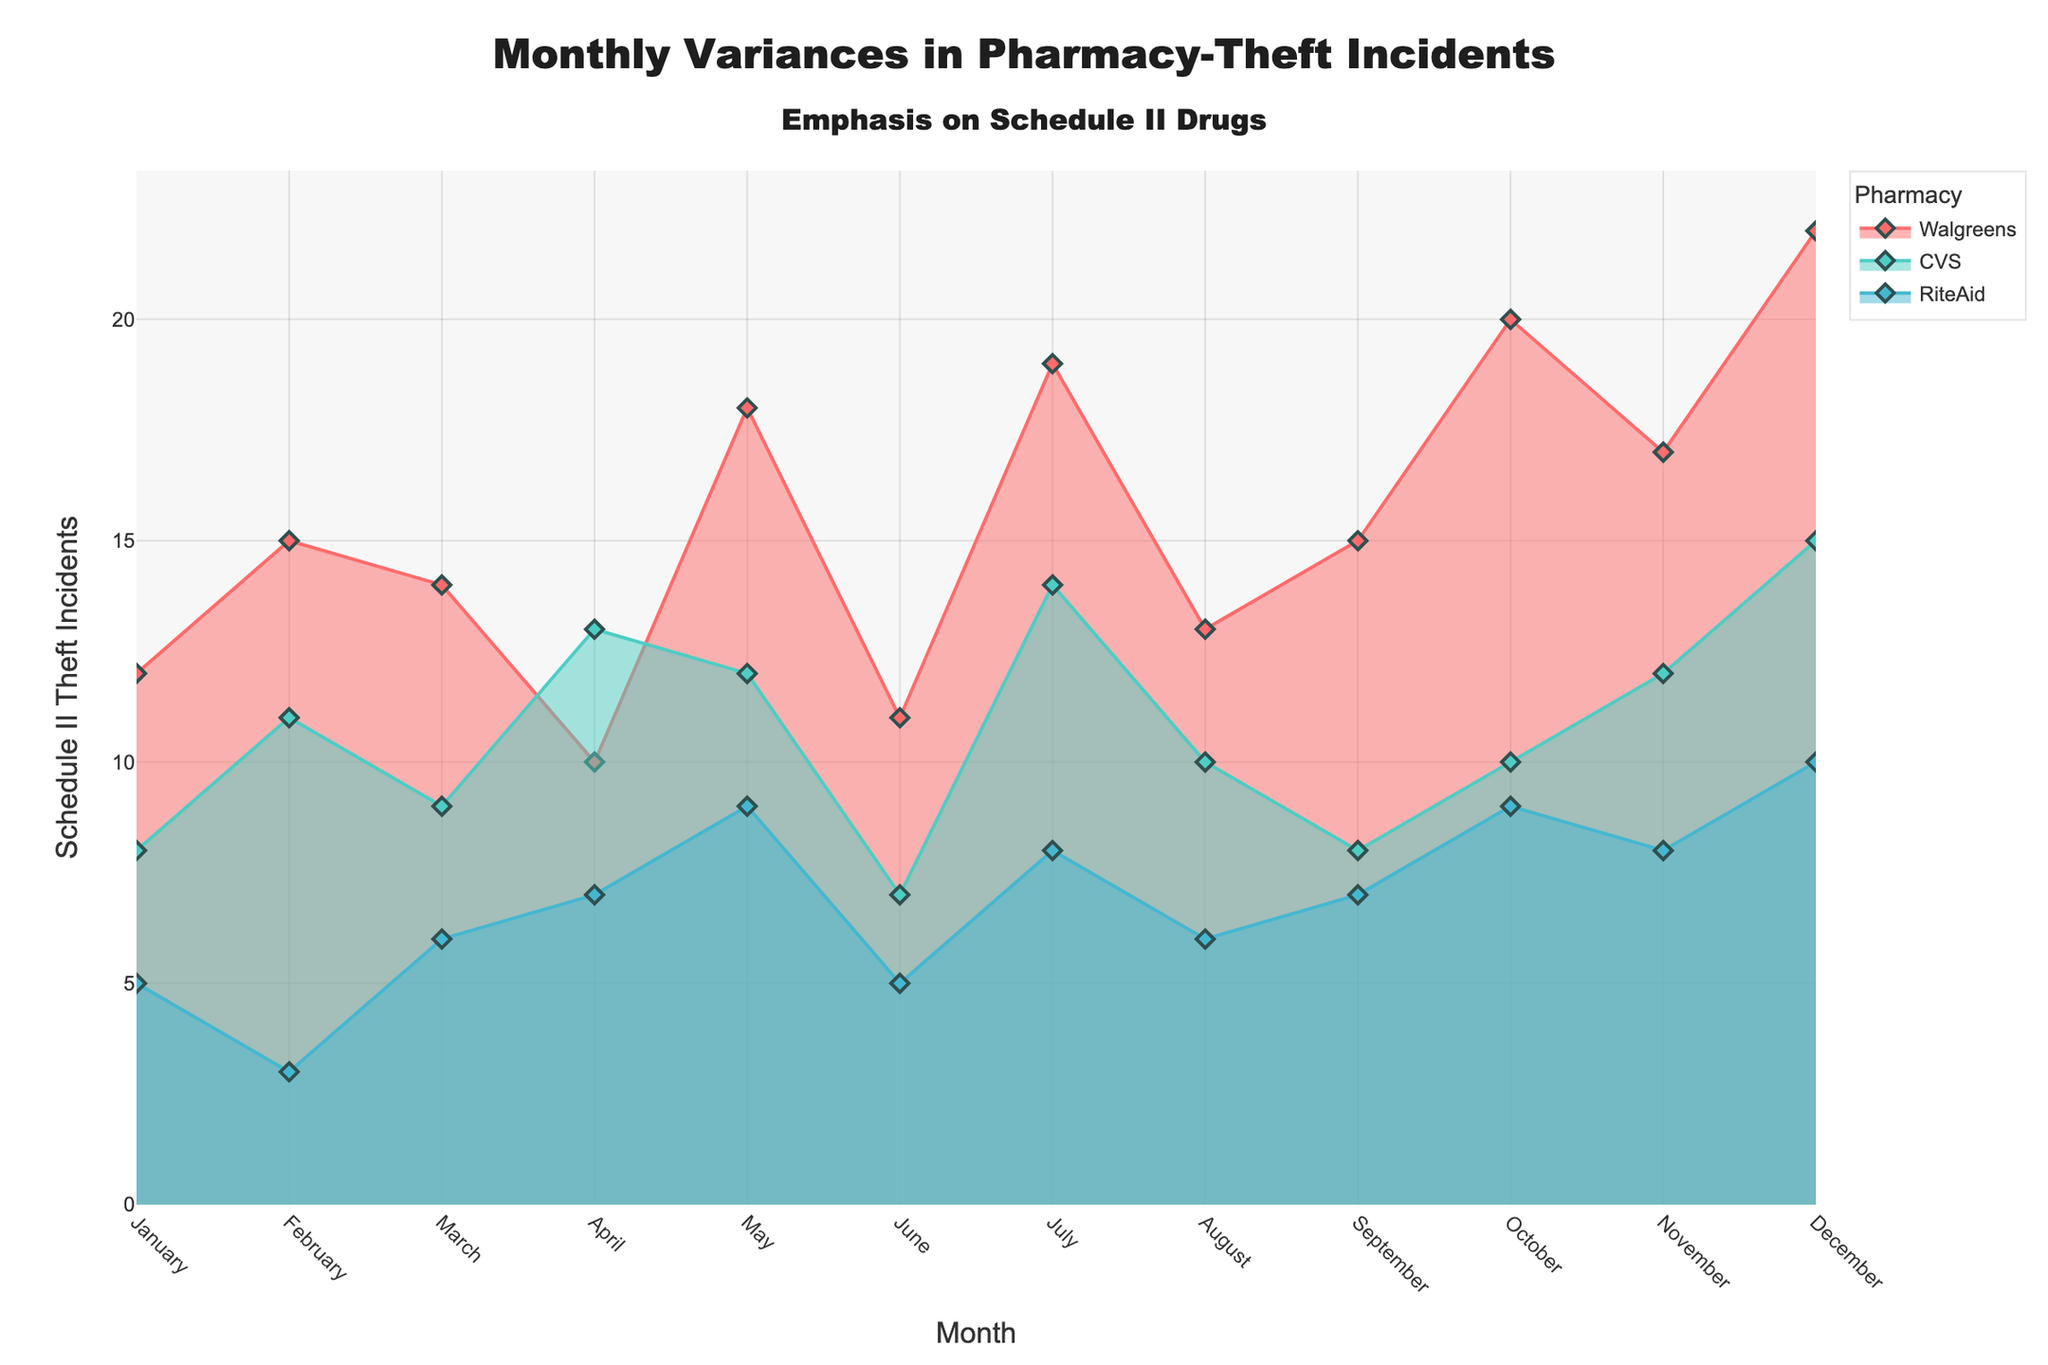What's the title of the chart? The title of the chart is placed at the top and clearly describes the content. It serves to help the viewer quickly understand what the chart is about.
Answer: Monthly Variances in Pharmacy-Theft Incidents What month had the highest number of Schedule II theft incidents at Walgreens? To find the month with the highest incidents at Walgreens, look for the highest peak in the Walgreens line (colored in a specific shade) and read the corresponding month from the x-axis.
Answer: December Which pharmacy had the least number of Schedule II theft incidents in February? Examine the data points for February for all three pharmacies and identify which data point has the smallest value on the y-axis.
Answer: RiteAid How does the number of theft incidents in April at CVS compare to those in March? Check the y-values for CVS (colored in a specific shade) at April and March and compare them.
Answer: April's incidents were higher What's the sum of Schedule II theft incidents for Walgreens in the first quarter (January to March)? Find the data points for Walgreens in January, February, and March, and add these values together.
Answer: 41 Which month saw the steepest increase in theft incidents for any pharmacy? Look for the month-to-month transitions and identify the steepest upward slope in any of the pharmacy lines.
Answer: July-August for Walgreens What is the average number of Schedule II theft incidents at RiteAid over the entire year? Add up all the monthly incidents for RiteAid, then divide the sum by 12 (number of months). Detailed calculation: (5+3+6+7+9+5+8+6+7+9+8+10)/12 = 7.17
Answer: 7.17 How does the pattern of theft incidents at CVS in the last quarter (October to December) compare to the first quarter (January to March)? Identify the trend from October to December and compare it with the trend from January to March for CVS, looking at both the increase or decrease and the overall pattern of values.
Answer: Both quarters saw an increase, but the last quarter had a higher starting and ending value Which month shows the greatest discrepancy between the number of incidents at Walgreens and CVS? Look for the month where the difference between the y-values of Walgreens and CVS is the largest.
Answer: December Is there a month where all three pharmacies had the same number of theft incidents? Scan through each month and check if there is a month where the y-values for all three lines (pharmacies) converge to the same value.
Answer: No 